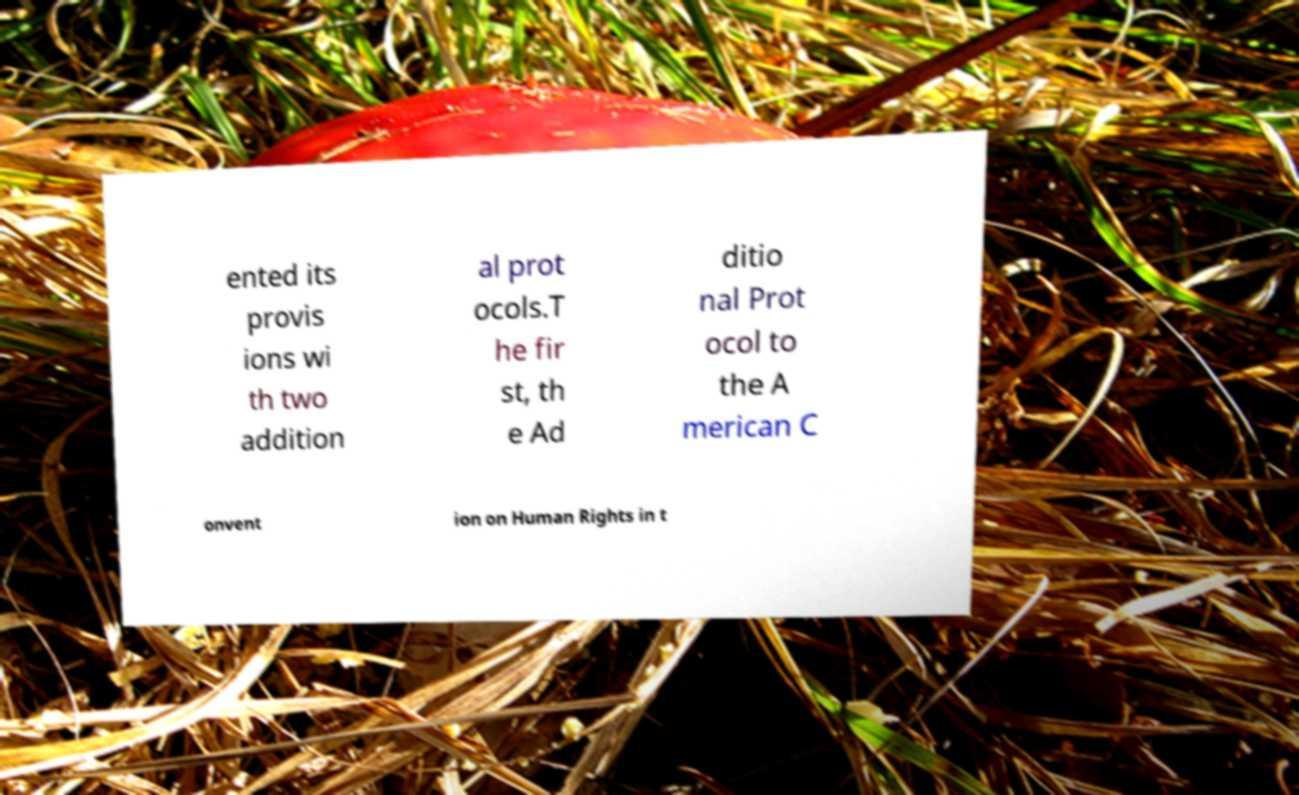Could you assist in decoding the text presented in this image and type it out clearly? ented its provis ions wi th two addition al prot ocols.T he fir st, th e Ad ditio nal Prot ocol to the A merican C onvent ion on Human Rights in t 